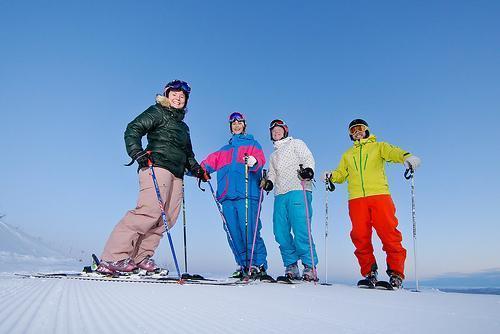How many people are there?
Give a very brief answer. 4. 